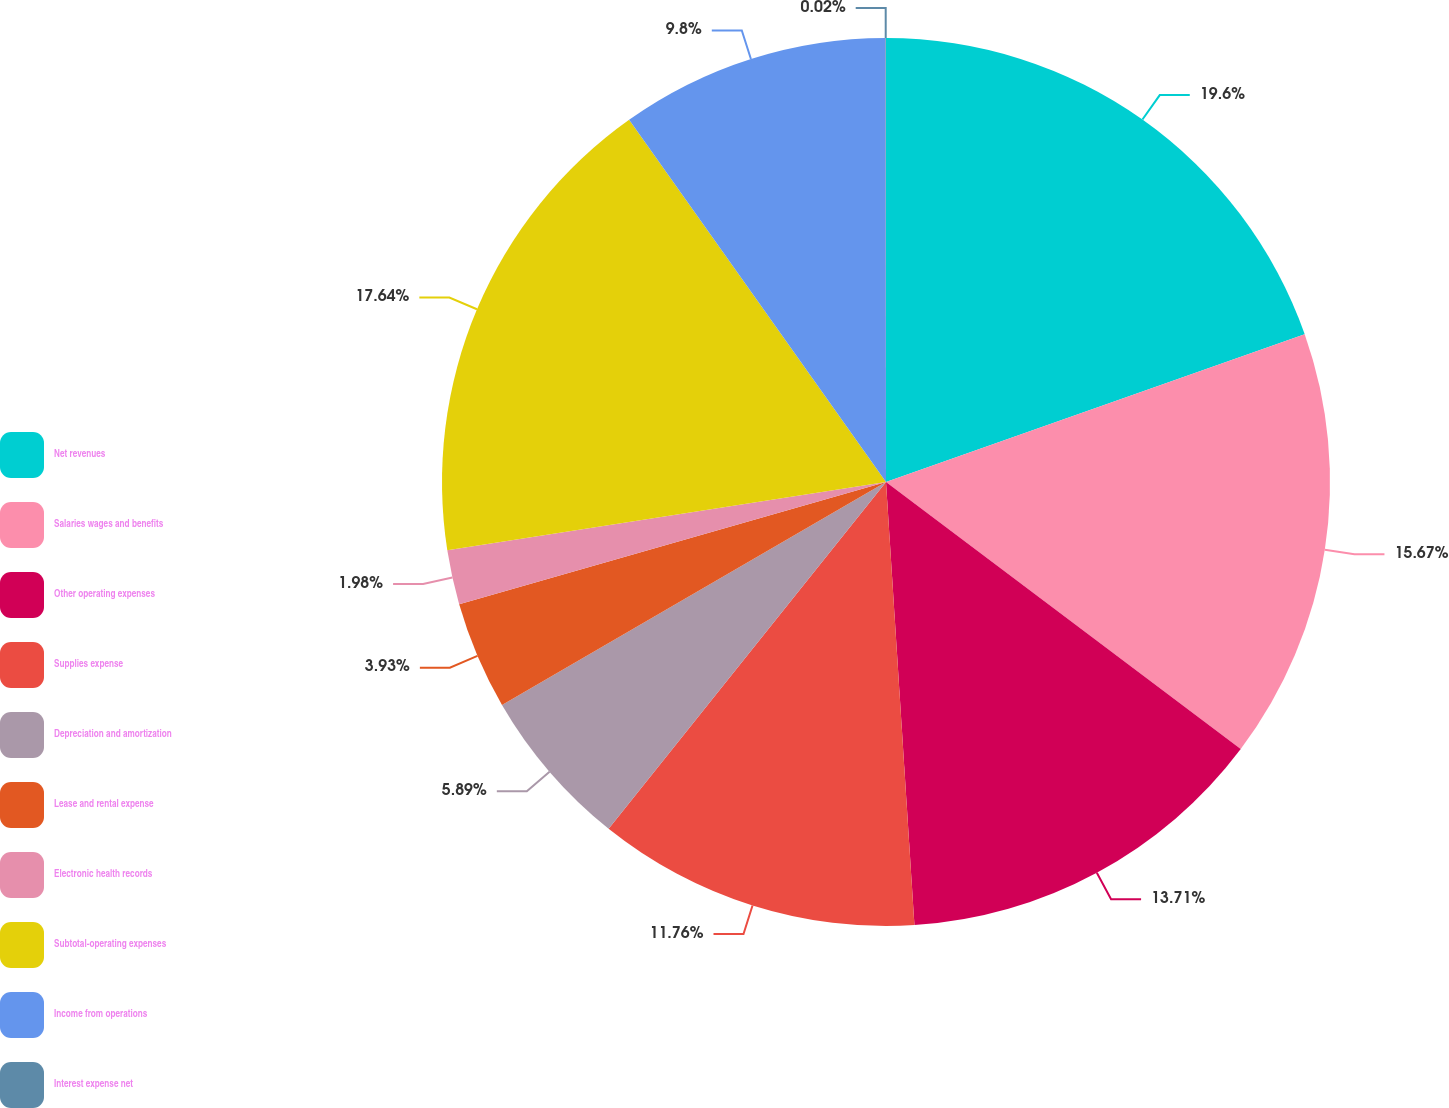Convert chart to OTSL. <chart><loc_0><loc_0><loc_500><loc_500><pie_chart><fcel>Net revenues<fcel>Salaries wages and benefits<fcel>Other operating expenses<fcel>Supplies expense<fcel>Depreciation and amortization<fcel>Lease and rental expense<fcel>Electronic health records<fcel>Subtotal-operating expenses<fcel>Income from operations<fcel>Interest expense net<nl><fcel>19.6%<fcel>15.67%<fcel>13.71%<fcel>11.76%<fcel>5.89%<fcel>3.93%<fcel>1.98%<fcel>17.64%<fcel>9.8%<fcel>0.02%<nl></chart> 